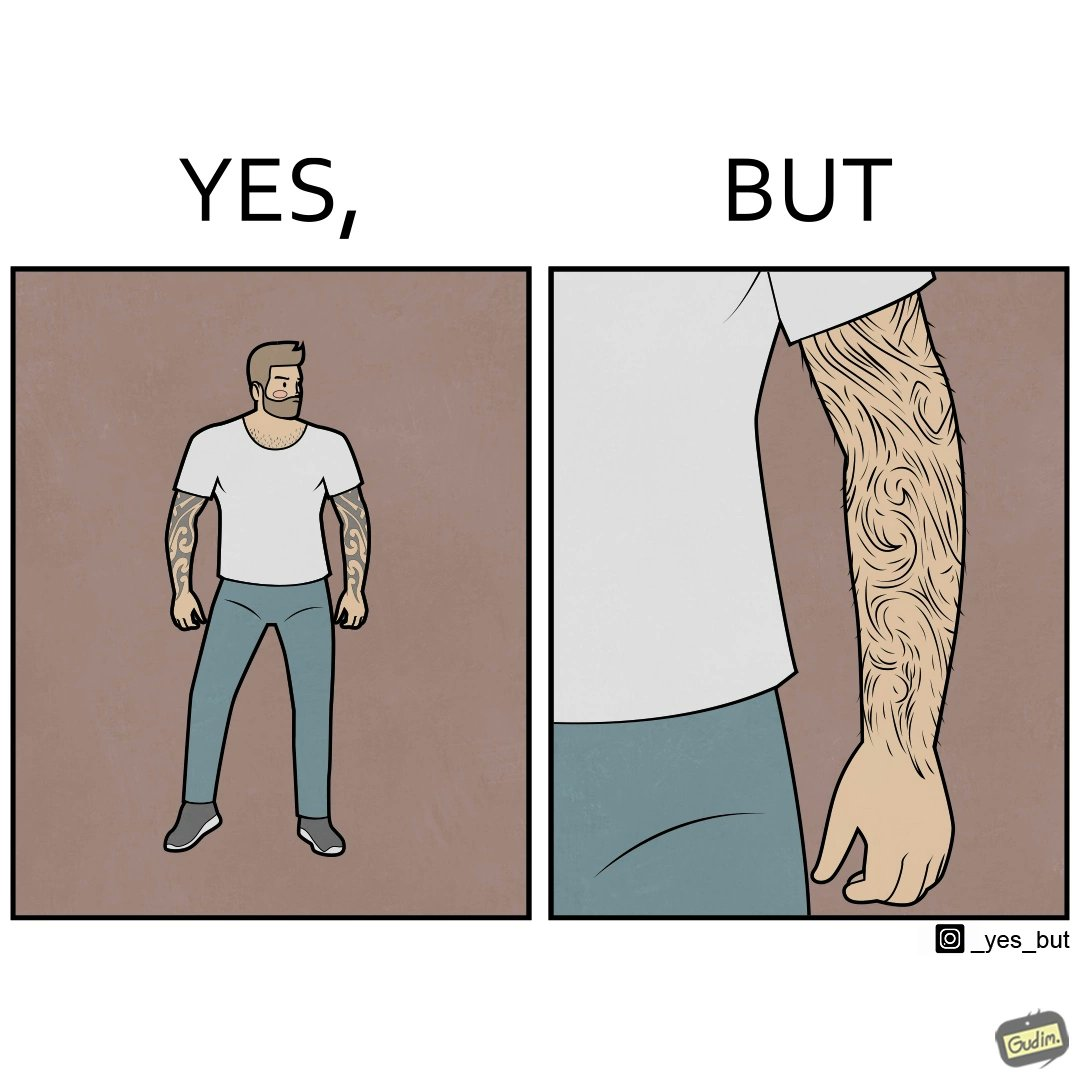Compare the left and right sides of this image. In the left part of the image: The image shows a man with tattoos on both of his arms. He is wearing white T-shirt . In the right part of the image: The image shows a closeup of an arm. The arm is shown to be very hairy and the hairs are wavy. 